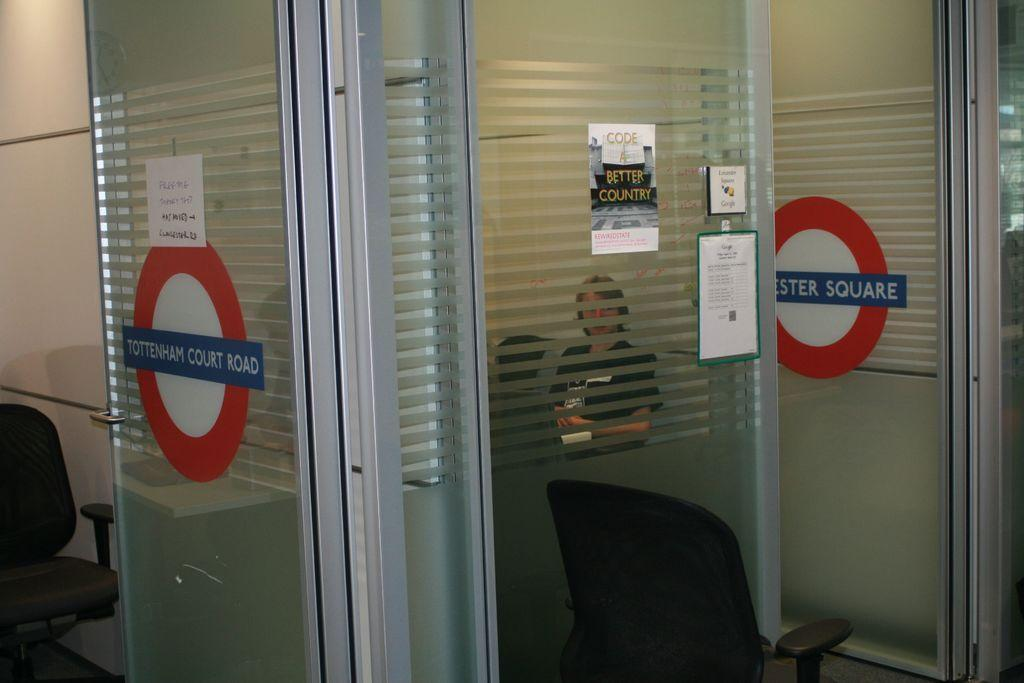What type of structure is visible in the image? There is a glass window in the image. What is located in front of the glass window? There is a chair in front of the glass window. Who is behind the glass window? A woman is sitting behind the glass window. What safety measures are in place in the image? There are caution boards on the doors. What type of cave can be seen in the background of the image? There is no cave present in the image; it features a glass window, a chair, a woman, and caution boards on the doors. What color is the yarn used to knit the cannon in the image? There is no yarn or cannon present in the image. 